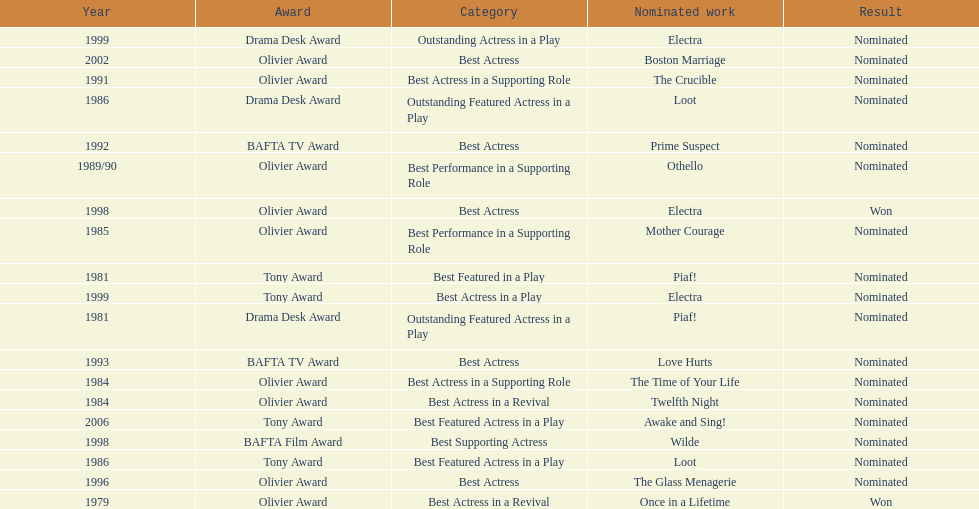What play was wanamaker nominated for best actress in a revival in 1984? Twelfth Night. 